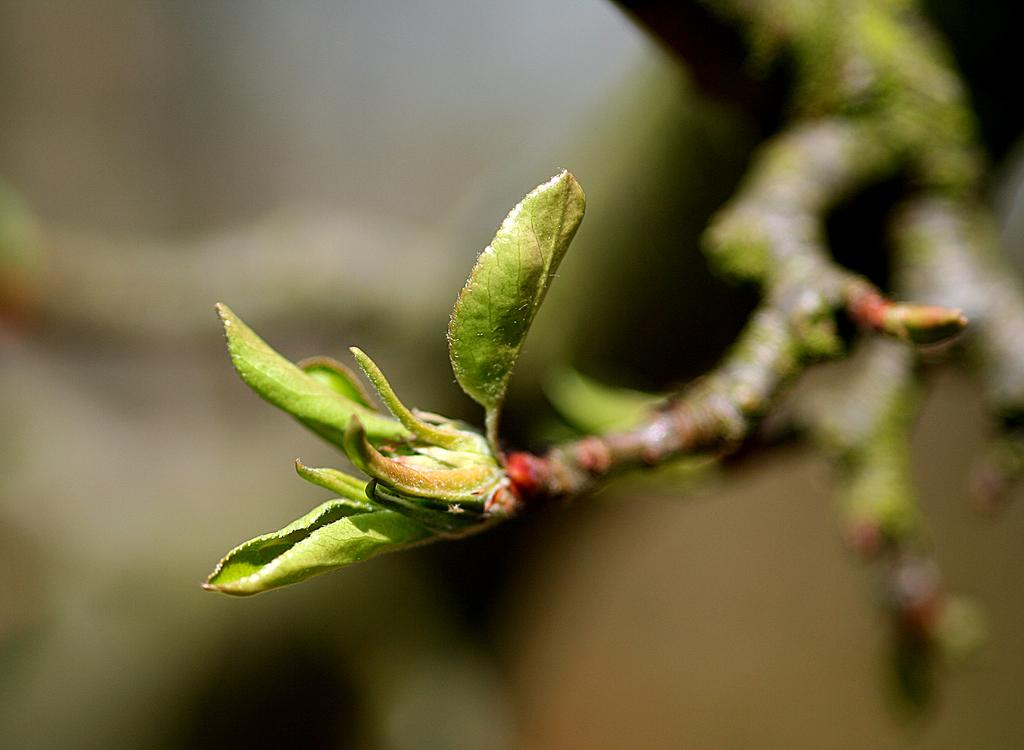What type of plant material is visible in the image? There are leaves and stems in the image. Can you see any office supplies in the image? There are no office supplies present in the image. What type of environment is depicted in the image? The image does not clearly depict a specific environment, such as an office or wilderness. Is there an umbrella visible in the image? There is no umbrella present in the image. 